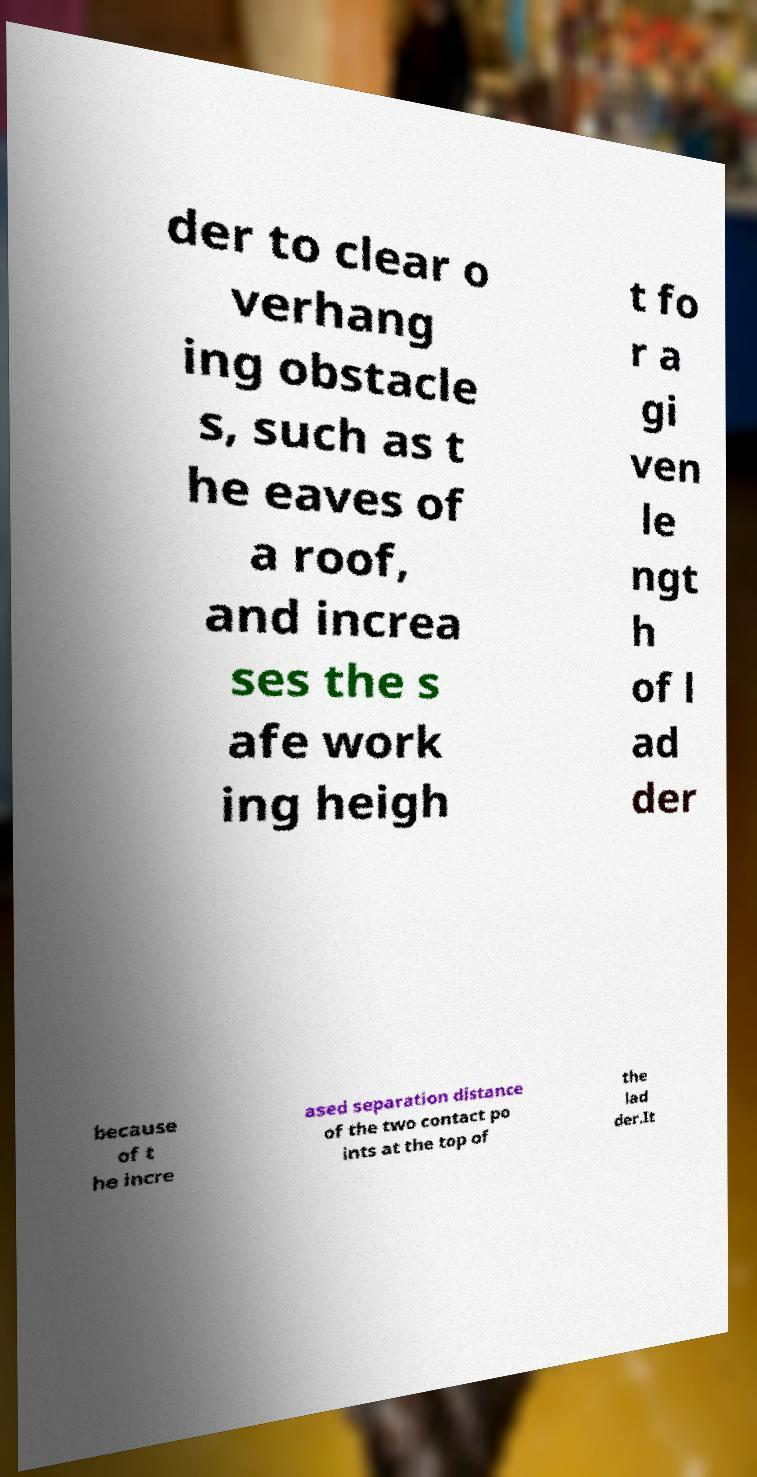Can you read and provide the text displayed in the image?This photo seems to have some interesting text. Can you extract and type it out for me? der to clear o verhang ing obstacle s, such as t he eaves of a roof, and increa ses the s afe work ing heigh t fo r a gi ven le ngt h of l ad der because of t he incre ased separation distance of the two contact po ints at the top of the lad der.It 